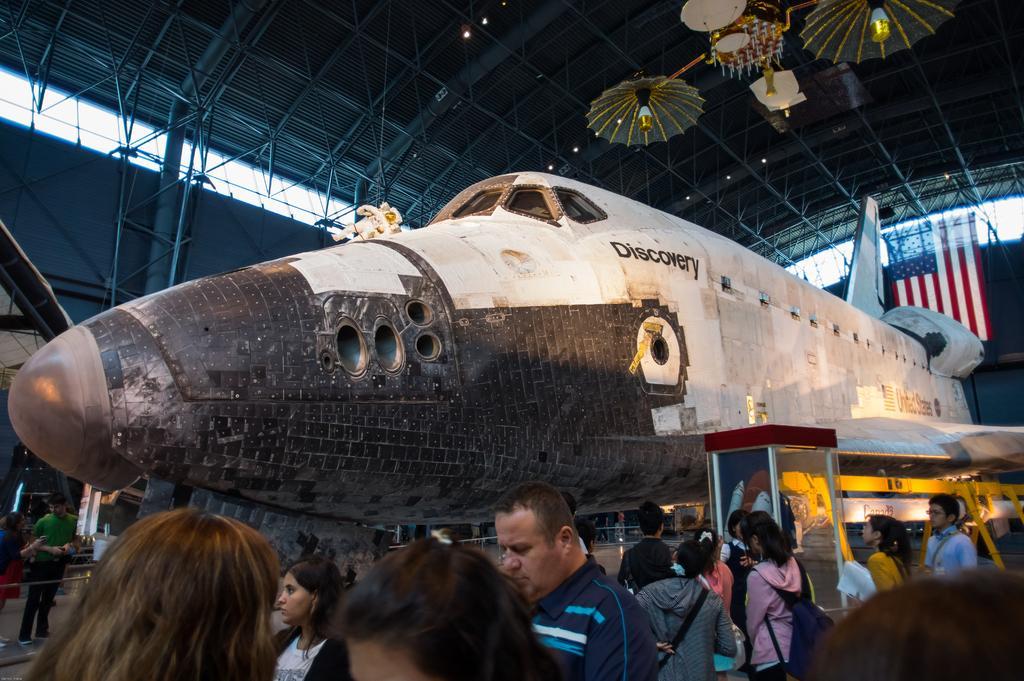Please provide a concise description of this image. In this image I can see in the middle there is an aeroplane under construction. At the bottom a group of people are looking at this thing, at the top there is an iron roof. 